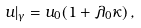<formula> <loc_0><loc_0><loc_500><loc_500>u | _ { \gamma } = u _ { 0 } ( 1 + \lambda _ { 0 } \kappa ) \, ,</formula> 